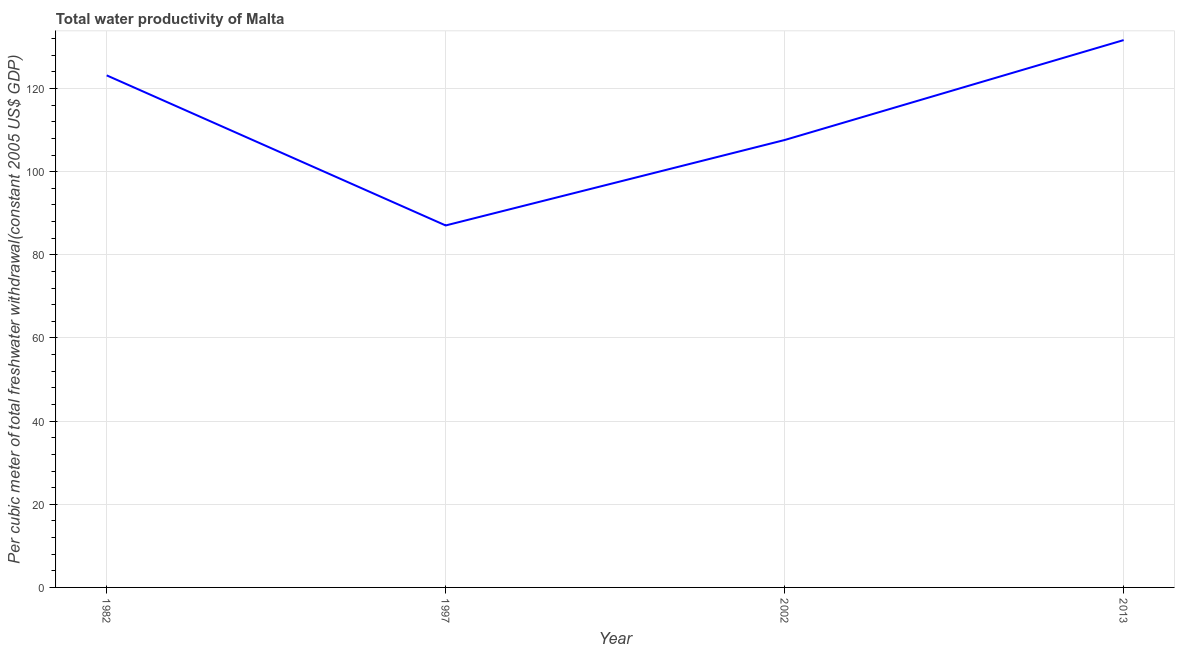What is the total water productivity in 2002?
Offer a terse response. 107.61. Across all years, what is the maximum total water productivity?
Ensure brevity in your answer.  131.65. Across all years, what is the minimum total water productivity?
Offer a very short reply. 87.06. In which year was the total water productivity maximum?
Offer a terse response. 2013. What is the sum of the total water productivity?
Offer a very short reply. 449.48. What is the difference between the total water productivity in 1982 and 2013?
Ensure brevity in your answer.  -8.48. What is the average total water productivity per year?
Your answer should be very brief. 112.37. What is the median total water productivity?
Make the answer very short. 115.39. In how many years, is the total water productivity greater than 24 US$?
Your answer should be compact. 4. Do a majority of the years between 1997 and 2002 (inclusive) have total water productivity greater than 64 US$?
Your answer should be very brief. Yes. What is the ratio of the total water productivity in 1997 to that in 2002?
Your response must be concise. 0.81. Is the total water productivity in 1982 less than that in 2013?
Ensure brevity in your answer.  Yes. What is the difference between the highest and the second highest total water productivity?
Give a very brief answer. 8.48. What is the difference between the highest and the lowest total water productivity?
Keep it short and to the point. 44.58. How many lines are there?
Give a very brief answer. 1. How many years are there in the graph?
Ensure brevity in your answer.  4. What is the difference between two consecutive major ticks on the Y-axis?
Offer a very short reply. 20. Does the graph contain grids?
Your answer should be compact. Yes. What is the title of the graph?
Provide a short and direct response. Total water productivity of Malta. What is the label or title of the X-axis?
Ensure brevity in your answer.  Year. What is the label or title of the Y-axis?
Keep it short and to the point. Per cubic meter of total freshwater withdrawal(constant 2005 US$ GDP). What is the Per cubic meter of total freshwater withdrawal(constant 2005 US$ GDP) of 1982?
Keep it short and to the point. 123.16. What is the Per cubic meter of total freshwater withdrawal(constant 2005 US$ GDP) of 1997?
Offer a very short reply. 87.06. What is the Per cubic meter of total freshwater withdrawal(constant 2005 US$ GDP) of 2002?
Make the answer very short. 107.61. What is the Per cubic meter of total freshwater withdrawal(constant 2005 US$ GDP) of 2013?
Provide a succinct answer. 131.65. What is the difference between the Per cubic meter of total freshwater withdrawal(constant 2005 US$ GDP) in 1982 and 1997?
Your response must be concise. 36.1. What is the difference between the Per cubic meter of total freshwater withdrawal(constant 2005 US$ GDP) in 1982 and 2002?
Offer a very short reply. 15.55. What is the difference between the Per cubic meter of total freshwater withdrawal(constant 2005 US$ GDP) in 1982 and 2013?
Your answer should be compact. -8.48. What is the difference between the Per cubic meter of total freshwater withdrawal(constant 2005 US$ GDP) in 1997 and 2002?
Give a very brief answer. -20.55. What is the difference between the Per cubic meter of total freshwater withdrawal(constant 2005 US$ GDP) in 1997 and 2013?
Provide a short and direct response. -44.58. What is the difference between the Per cubic meter of total freshwater withdrawal(constant 2005 US$ GDP) in 2002 and 2013?
Your answer should be compact. -24.03. What is the ratio of the Per cubic meter of total freshwater withdrawal(constant 2005 US$ GDP) in 1982 to that in 1997?
Offer a terse response. 1.42. What is the ratio of the Per cubic meter of total freshwater withdrawal(constant 2005 US$ GDP) in 1982 to that in 2002?
Your answer should be very brief. 1.14. What is the ratio of the Per cubic meter of total freshwater withdrawal(constant 2005 US$ GDP) in 1982 to that in 2013?
Give a very brief answer. 0.94. What is the ratio of the Per cubic meter of total freshwater withdrawal(constant 2005 US$ GDP) in 1997 to that in 2002?
Offer a very short reply. 0.81. What is the ratio of the Per cubic meter of total freshwater withdrawal(constant 2005 US$ GDP) in 1997 to that in 2013?
Your answer should be compact. 0.66. What is the ratio of the Per cubic meter of total freshwater withdrawal(constant 2005 US$ GDP) in 2002 to that in 2013?
Offer a very short reply. 0.82. 